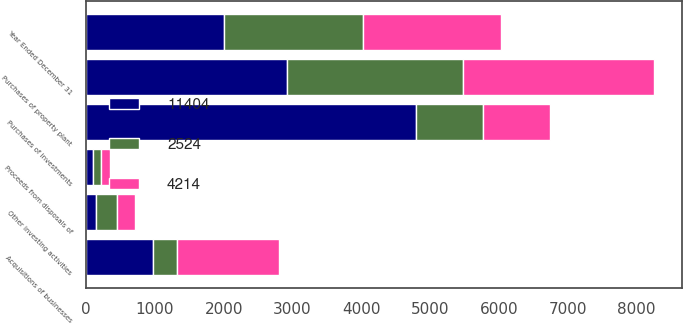<chart> <loc_0><loc_0><loc_500><loc_500><stacked_bar_chart><ecel><fcel>Year Ended December 31<fcel>Purchases of investments<fcel>Proceeds from disposals of<fcel>Acquisitions of businesses<fcel>Purchases of property plant<fcel>Other investing activities<nl><fcel>2524<fcel>2013<fcel>971<fcel>111<fcel>353<fcel>2550<fcel>303<nl><fcel>4214<fcel>2012<fcel>971<fcel>143<fcel>1486<fcel>2780<fcel>268<nl><fcel>11404<fcel>2011<fcel>4798<fcel>101<fcel>971<fcel>2920<fcel>145<nl></chart> 